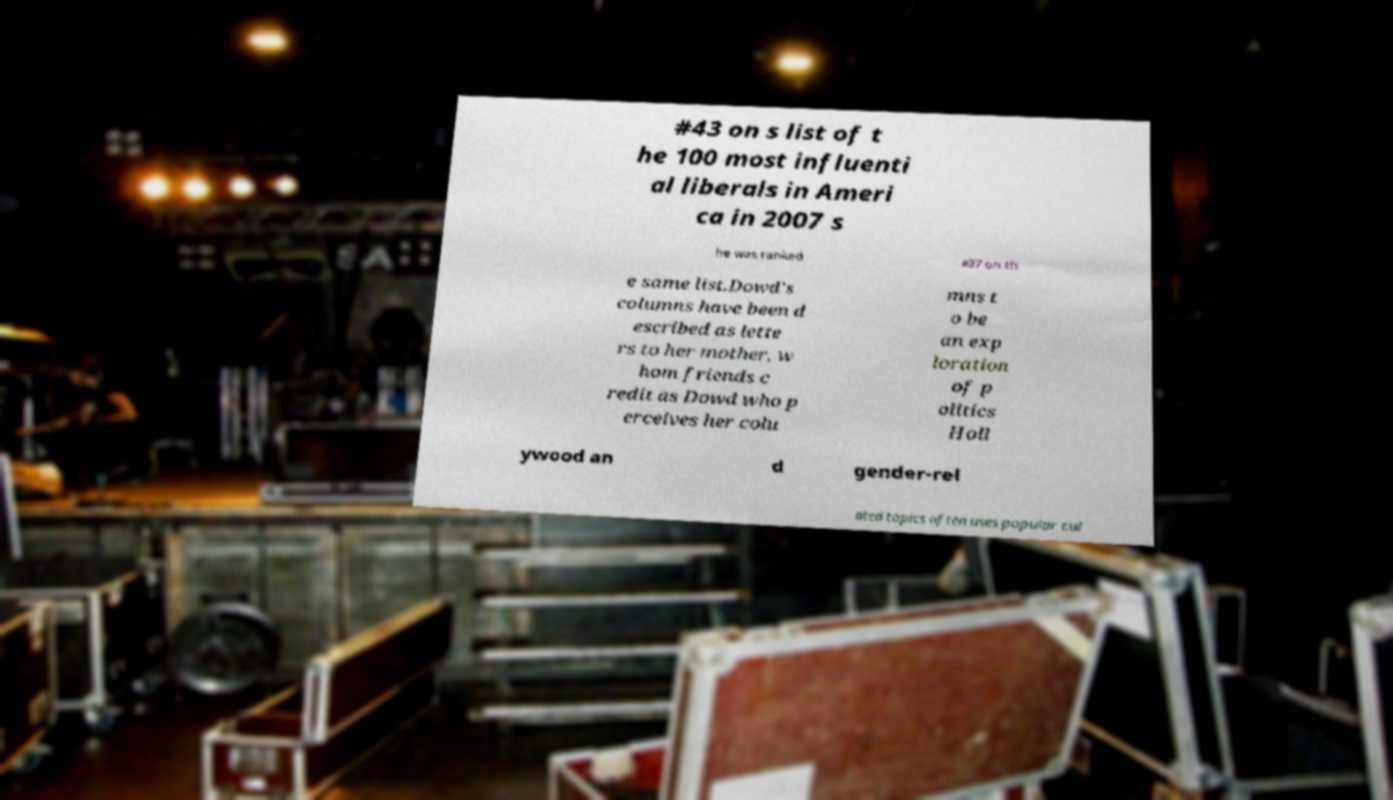Please read and relay the text visible in this image. What does it say? #43 on s list of t he 100 most influenti al liberals in Ameri ca in 2007 s he was ranked #37 on th e same list.Dowd's columns have been d escribed as lette rs to her mother, w hom friends c redit as Dowd who p erceives her colu mns t o be an exp loration of p olitics Holl ywood an d gender-rel ated topics often uses popular cul 